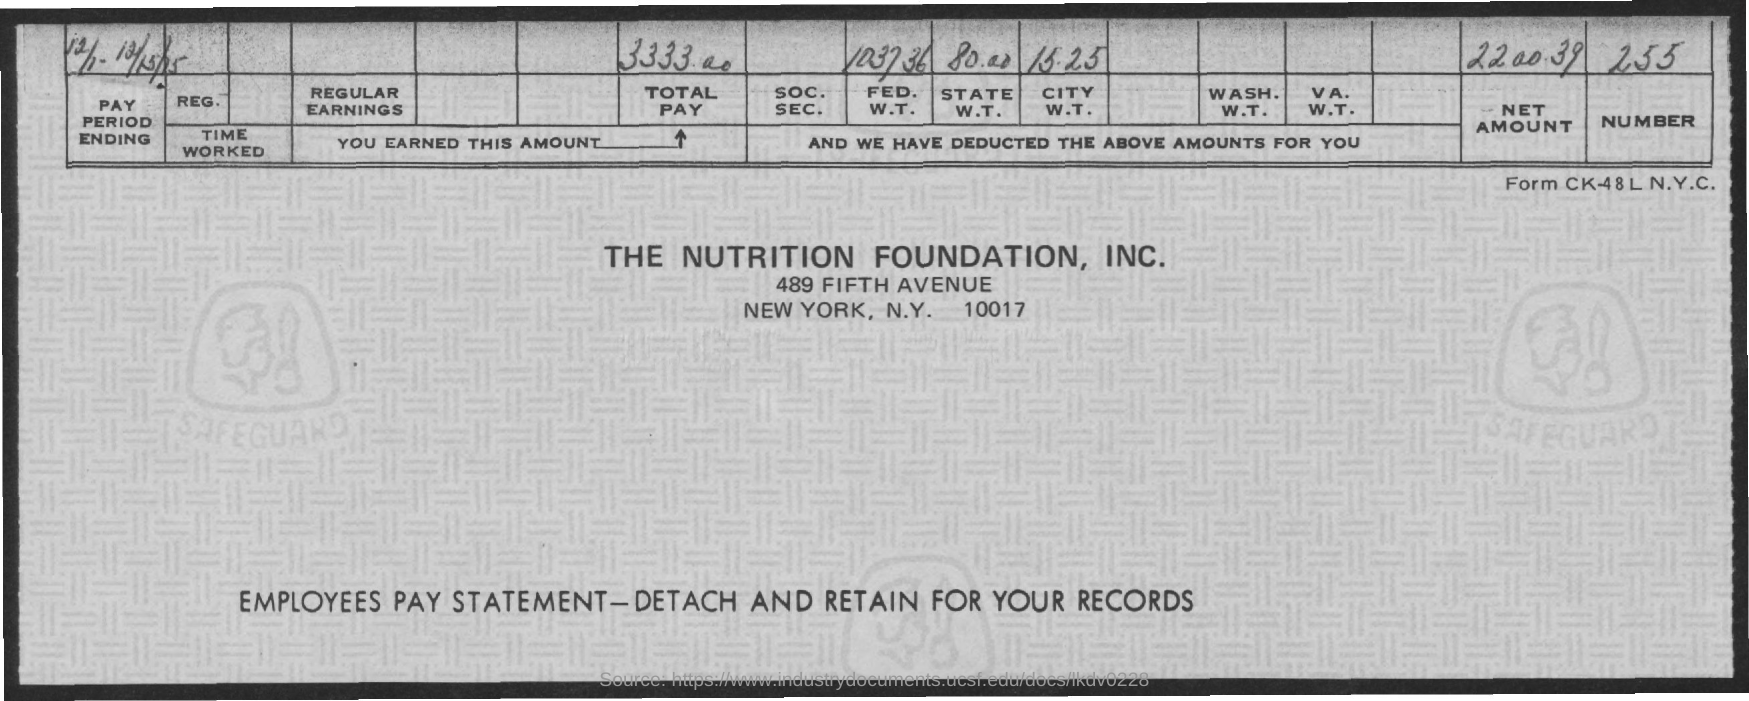What is the amount of total pay mentioned in the given page ?
Give a very brief answer. 3333.00. What is the number mentioned in the given page ?
Give a very brief answer. 255. What is the value of the net amount mentioned in the given page ?
Offer a very short reply. 2200.39. What is the amount for fed. w.t. as mentioned in the given page ?
Your response must be concise. 1037.36. What is the amount for city w.t. as mentioned in the given page ?
Provide a short and direct response. 15.25. What is the amount for state w.t. as mentioned in the given page ?
Provide a short and direct response. 80.00. 